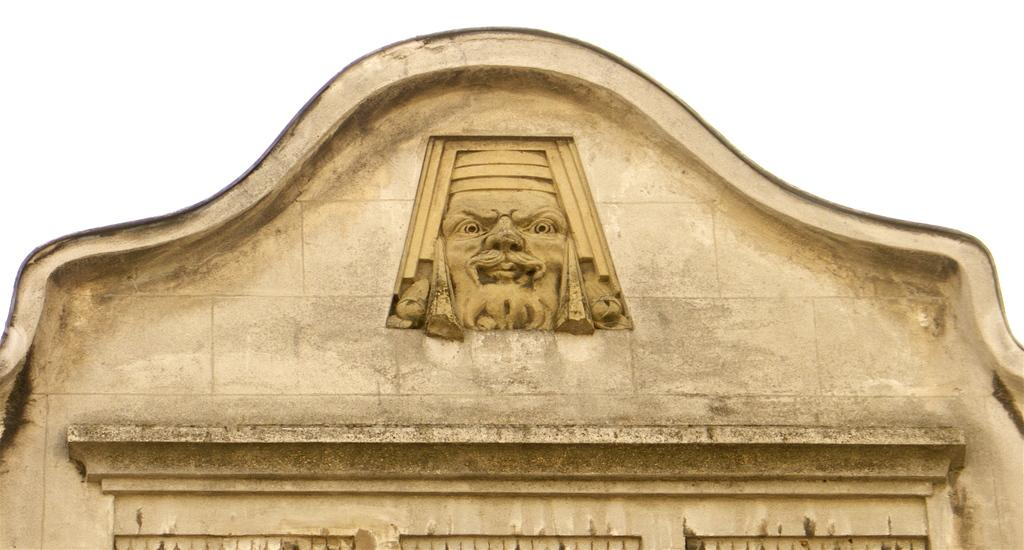What is the main subject of the image? The main subject of the image is the top of a building. Are there any specific features on the building? Yes, there is a carving of a man on the wall of the building. What type of grape is being used to decorate the top of the building in the image? There is no grape present in the image; it features the top of a building with a carving of a man on the wall. How many lettuce leaves are visible on the carving of the man in the image? There are no lettuce leaves present in the image; it features the top of a building with a carving of a man on the wall. 